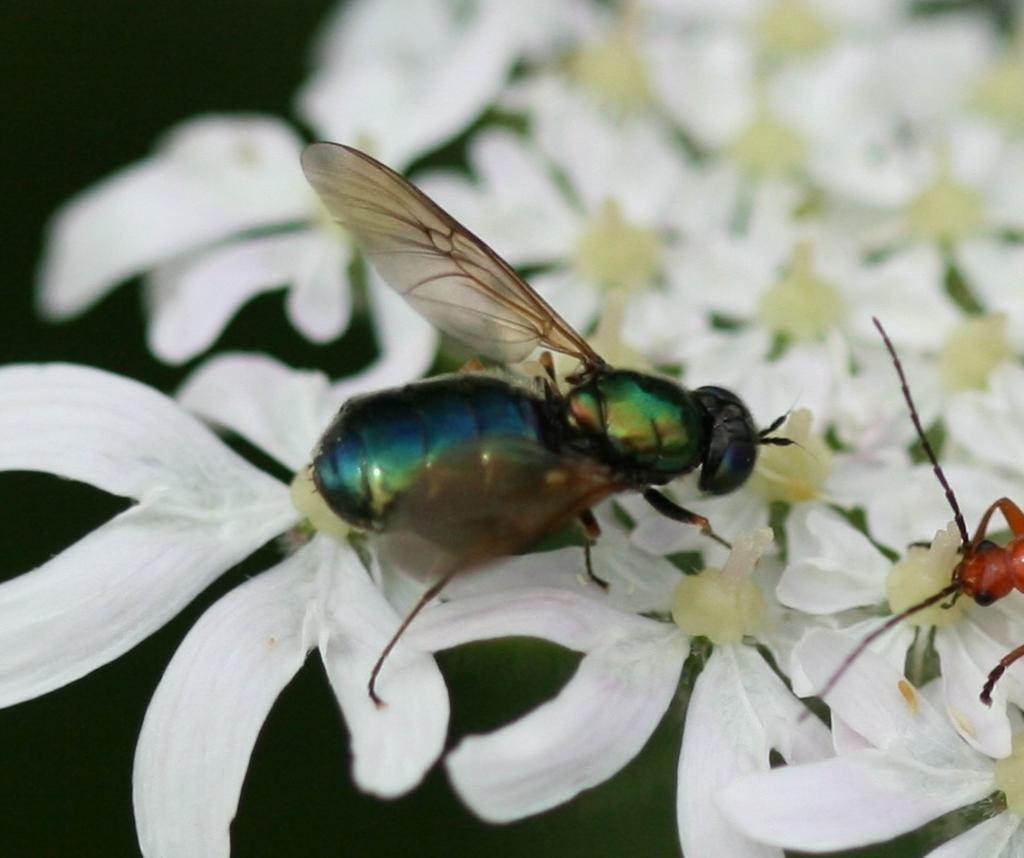Please provide a concise description of this image. In this image there is a Bee on the white color flowers. 